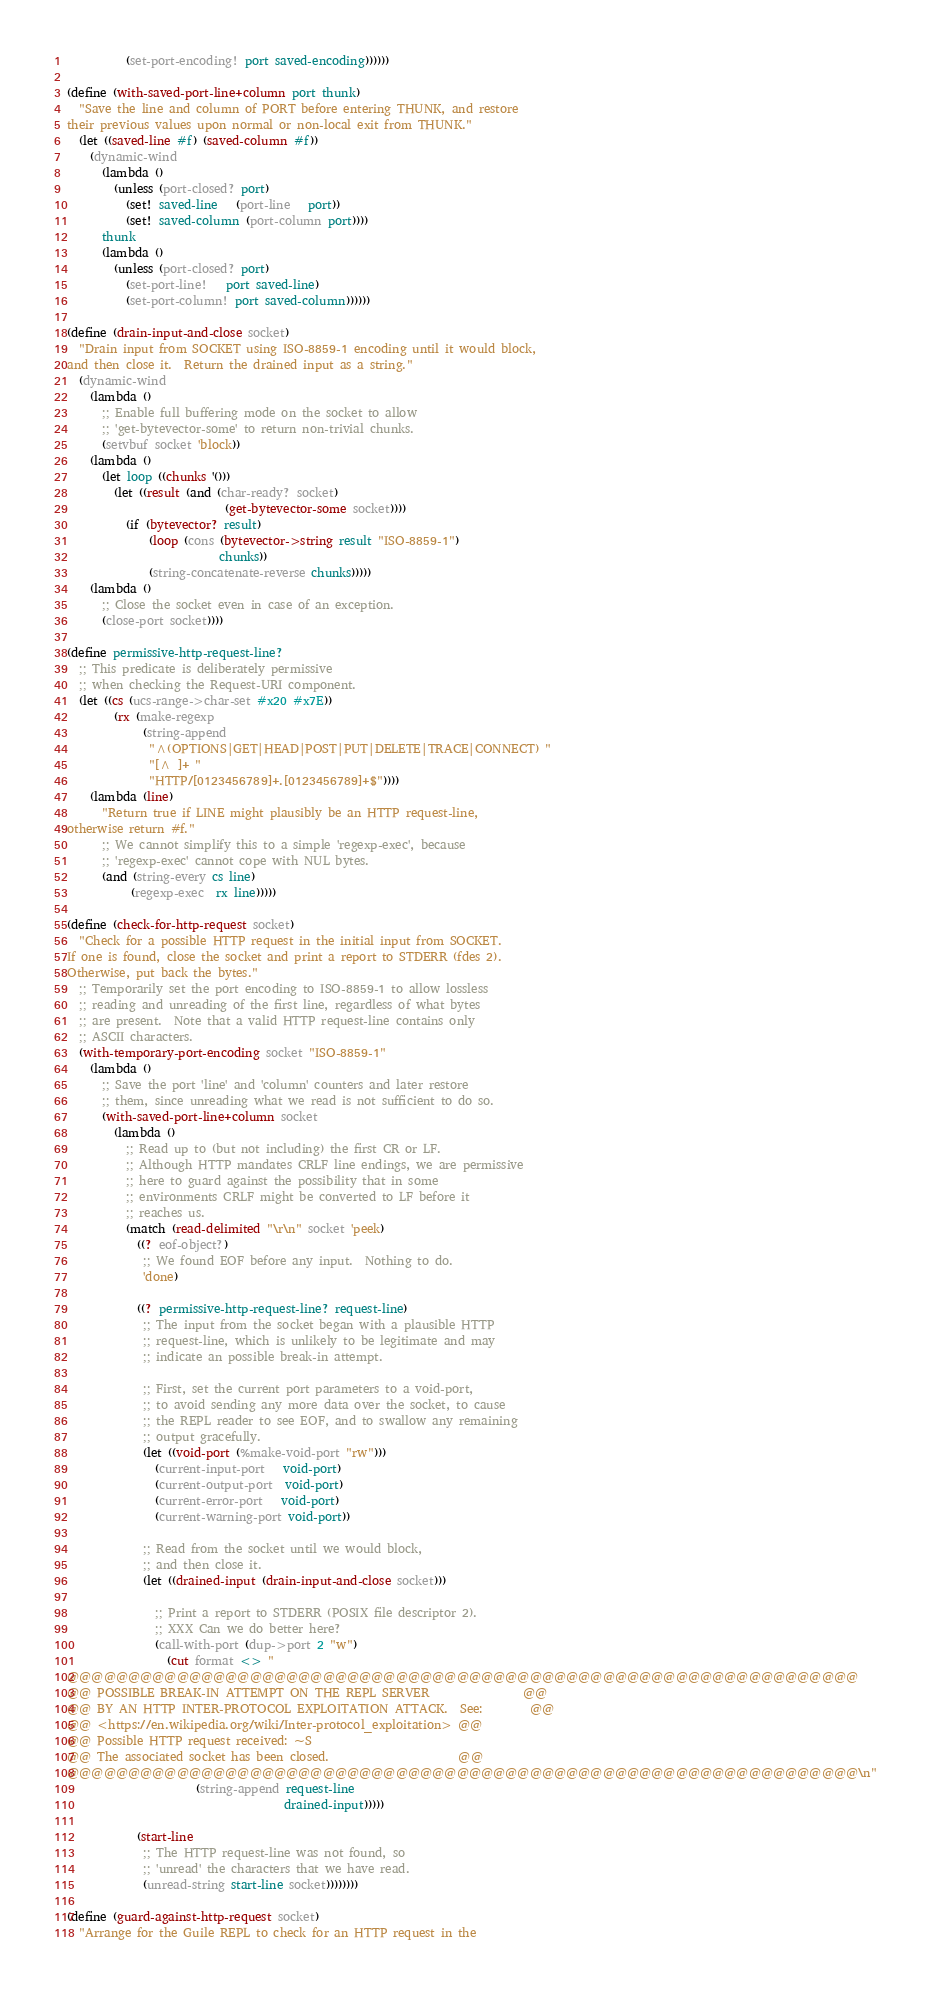<code> <loc_0><loc_0><loc_500><loc_500><_Scheme_>          (set-port-encoding! port saved-encoding))))))

(define (with-saved-port-line+column port thunk)
  "Save the line and column of PORT before entering THUNK, and restore
their previous values upon normal or non-local exit from THUNK."
  (let ((saved-line #f) (saved-column #f))
    (dynamic-wind
      (lambda ()
        (unless (port-closed? port)
          (set! saved-line   (port-line   port))
          (set! saved-column (port-column port))))
      thunk
      (lambda ()
        (unless (port-closed? port)
          (set-port-line!   port saved-line)
          (set-port-column! port saved-column))))))

(define (drain-input-and-close socket)
  "Drain input from SOCKET using ISO-8859-1 encoding until it would block,
and then close it.  Return the drained input as a string."
  (dynamic-wind
    (lambda ()
      ;; Enable full buffering mode on the socket to allow
      ;; 'get-bytevector-some' to return non-trivial chunks.
      (setvbuf socket 'block))
    (lambda ()
      (let loop ((chunks '()))
        (let ((result (and (char-ready? socket)
                           (get-bytevector-some socket))))
          (if (bytevector? result)
              (loop (cons (bytevector->string result "ISO-8859-1")
                          chunks))
              (string-concatenate-reverse chunks)))))
    (lambda ()
      ;; Close the socket even in case of an exception.
      (close-port socket))))

(define permissive-http-request-line?
  ;; This predicate is deliberately permissive
  ;; when checking the Request-URI component.
  (let ((cs (ucs-range->char-set #x20 #x7E))
        (rx (make-regexp
             (string-append
              "^(OPTIONS|GET|HEAD|POST|PUT|DELETE|TRACE|CONNECT) "
              "[^ ]+ "
              "HTTP/[0123456789]+.[0123456789]+$"))))
    (lambda (line)
      "Return true if LINE might plausibly be an HTTP request-line,
otherwise return #f."
      ;; We cannot simplify this to a simple 'regexp-exec', because
      ;; 'regexp-exec' cannot cope with NUL bytes.
      (and (string-every cs line)
           (regexp-exec  rx line)))))

(define (check-for-http-request socket)
  "Check for a possible HTTP request in the initial input from SOCKET.
If one is found, close the socket and print a report to STDERR (fdes 2).
Otherwise, put back the bytes."
  ;; Temporarily set the port encoding to ISO-8859-1 to allow lossless
  ;; reading and unreading of the first line, regardless of what bytes
  ;; are present.  Note that a valid HTTP request-line contains only
  ;; ASCII characters.
  (with-temporary-port-encoding socket "ISO-8859-1"
    (lambda ()
      ;; Save the port 'line' and 'column' counters and later restore
      ;; them, since unreading what we read is not sufficient to do so.
      (with-saved-port-line+column socket
        (lambda ()
          ;; Read up to (but not including) the first CR or LF.
          ;; Although HTTP mandates CRLF line endings, we are permissive
          ;; here to guard against the possibility that in some
          ;; environments CRLF might be converted to LF before it
          ;; reaches us.
          (match (read-delimited "\r\n" socket 'peek)
            ((? eof-object?)
             ;; We found EOF before any input.  Nothing to do.
             'done)

            ((? permissive-http-request-line? request-line)
             ;; The input from the socket began with a plausible HTTP
             ;; request-line, which is unlikely to be legitimate and may
             ;; indicate an possible break-in attempt.

             ;; First, set the current port parameters to a void-port,
             ;; to avoid sending any more data over the socket, to cause
             ;; the REPL reader to see EOF, and to swallow any remaining
             ;; output gracefully.
             (let ((void-port (%make-void-port "rw")))
               (current-input-port   void-port)
               (current-output-port  void-port)
               (current-error-port   void-port)
               (current-warning-port void-port))

             ;; Read from the socket until we would block,
             ;; and then close it.
             (let ((drained-input (drain-input-and-close socket)))

               ;; Print a report to STDERR (POSIX file descriptor 2).
               ;; XXX Can we do better here?
               (call-with-port (dup->port 2 "w")
                 (cut format <> "
@@@@@@@@@@@@@@@@@@@@@@@@@@@@@@@@@@@@@@@@@@@@@@@@@@@@@@@@@@@@@@@@@
@@ POSSIBLE BREAK-IN ATTEMPT ON THE REPL SERVER                @@
@@ BY AN HTTP INTER-PROTOCOL EXPLOITATION ATTACK.  See:        @@
@@ <https://en.wikipedia.org/wiki/Inter-protocol_exploitation> @@
@@ Possible HTTP request received: ~S
@@ The associated socket has been closed.                      @@
@@@@@@@@@@@@@@@@@@@@@@@@@@@@@@@@@@@@@@@@@@@@@@@@@@@@@@@@@@@@@@@@@\n"
                      (string-append request-line
                                     drained-input)))))

            (start-line
             ;; The HTTP request-line was not found, so
             ;; 'unread' the characters that we have read.
             (unread-string start-line socket))))))))

(define (guard-against-http-request socket)
  "Arrange for the Guile REPL to check for an HTTP request in the</code> 